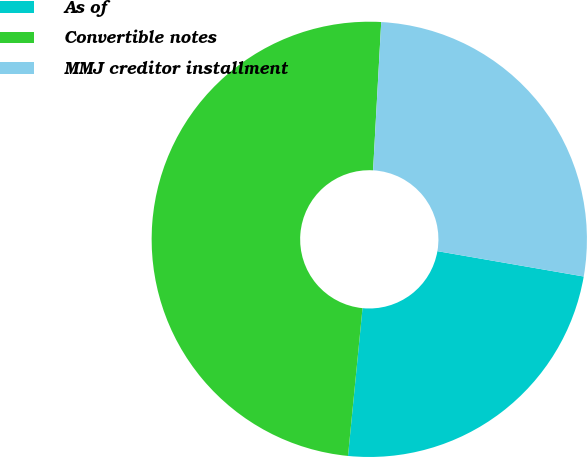<chart> <loc_0><loc_0><loc_500><loc_500><pie_chart><fcel>As of<fcel>Convertible notes<fcel>MMJ creditor installment<nl><fcel>23.83%<fcel>49.32%<fcel>26.86%<nl></chart> 